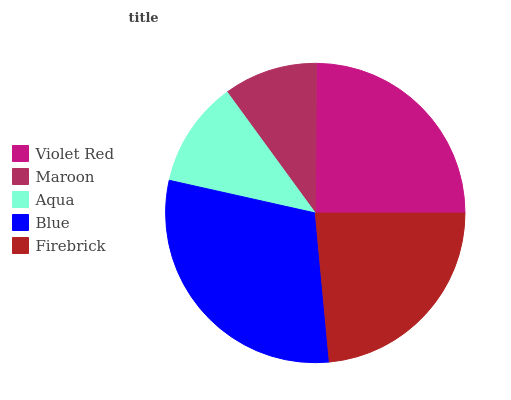Is Maroon the minimum?
Answer yes or no. Yes. Is Blue the maximum?
Answer yes or no. Yes. Is Aqua the minimum?
Answer yes or no. No. Is Aqua the maximum?
Answer yes or no. No. Is Aqua greater than Maroon?
Answer yes or no. Yes. Is Maroon less than Aqua?
Answer yes or no. Yes. Is Maroon greater than Aqua?
Answer yes or no. No. Is Aqua less than Maroon?
Answer yes or no. No. Is Firebrick the high median?
Answer yes or no. Yes. Is Firebrick the low median?
Answer yes or no. Yes. Is Aqua the high median?
Answer yes or no. No. Is Blue the low median?
Answer yes or no. No. 